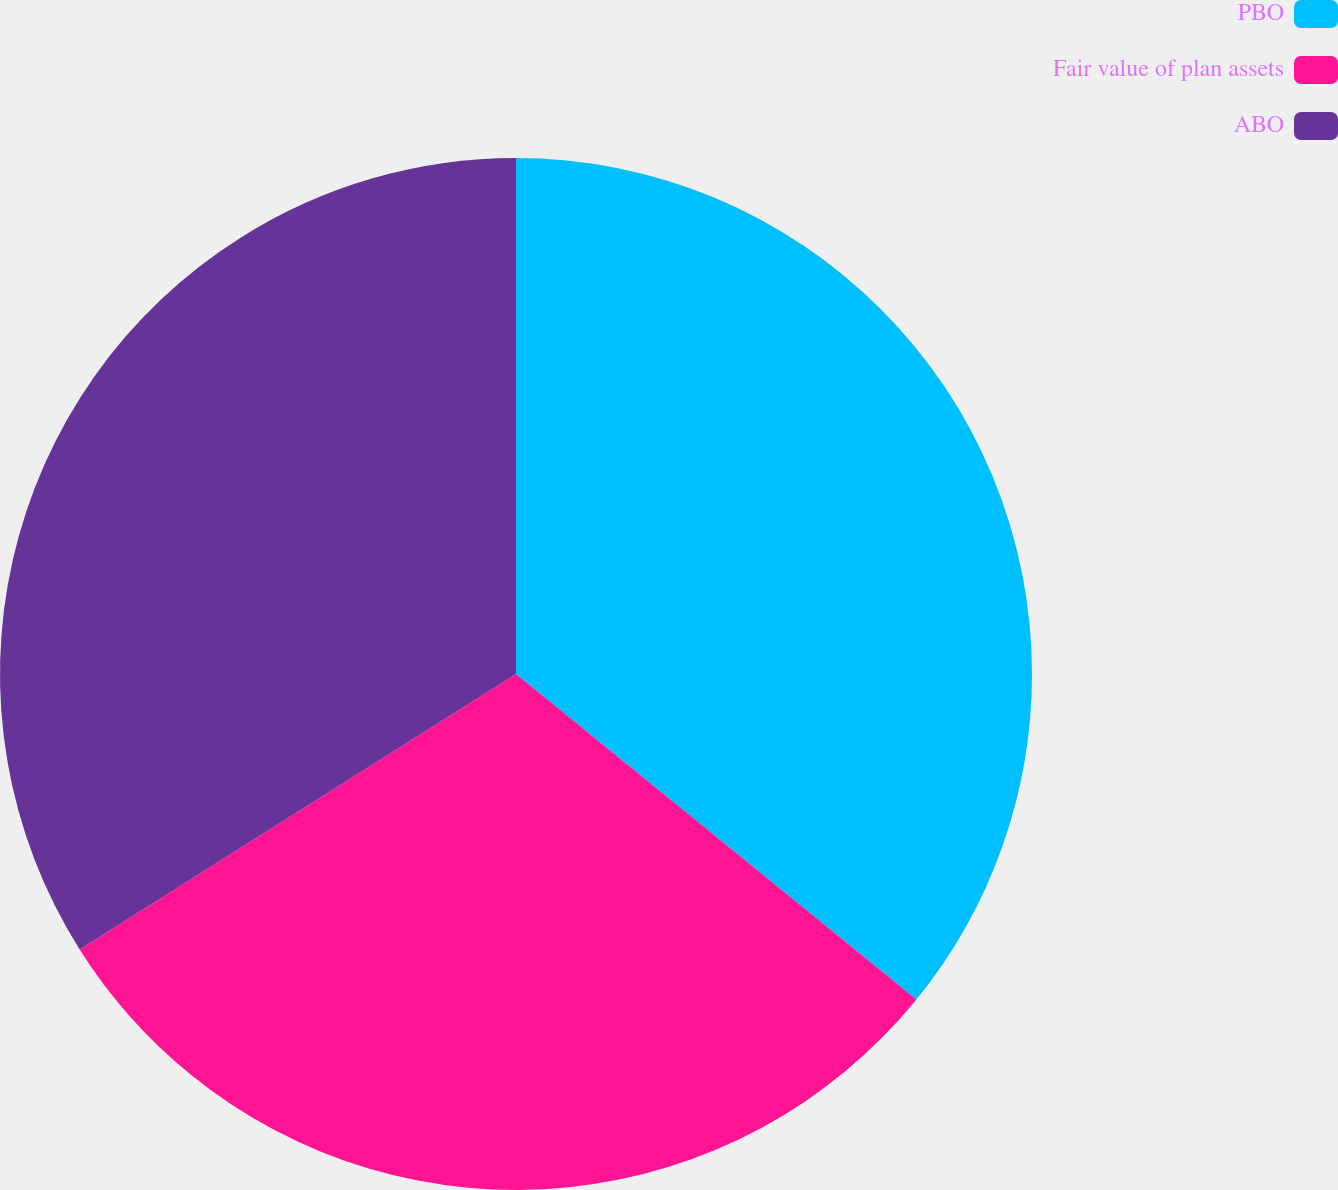Convert chart to OTSL. <chart><loc_0><loc_0><loc_500><loc_500><pie_chart><fcel>PBO<fcel>Fair value of plan assets<fcel>ABO<nl><fcel>35.86%<fcel>30.18%<fcel>33.96%<nl></chart> 